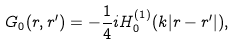<formula> <loc_0><loc_0><loc_500><loc_500>G _ { 0 } ( { r } , { r ^ { \prime } } ) = - \frac { 1 } { 4 } i H _ { 0 } ^ { ( 1 ) } ( k | { r } - { r ^ { \prime } } | ) ,</formula> 